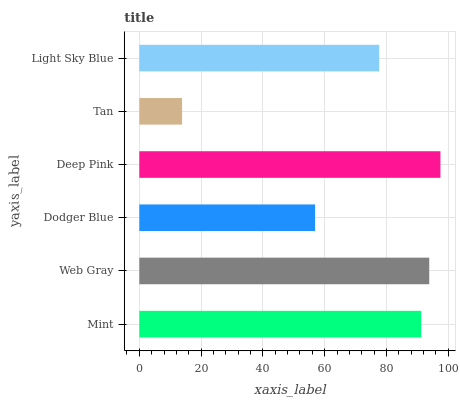Is Tan the minimum?
Answer yes or no. Yes. Is Deep Pink the maximum?
Answer yes or no. Yes. Is Web Gray the minimum?
Answer yes or no. No. Is Web Gray the maximum?
Answer yes or no. No. Is Web Gray greater than Mint?
Answer yes or no. Yes. Is Mint less than Web Gray?
Answer yes or no. Yes. Is Mint greater than Web Gray?
Answer yes or no. No. Is Web Gray less than Mint?
Answer yes or no. No. Is Mint the high median?
Answer yes or no. Yes. Is Light Sky Blue the low median?
Answer yes or no. Yes. Is Light Sky Blue the high median?
Answer yes or no. No. Is Mint the low median?
Answer yes or no. No. 